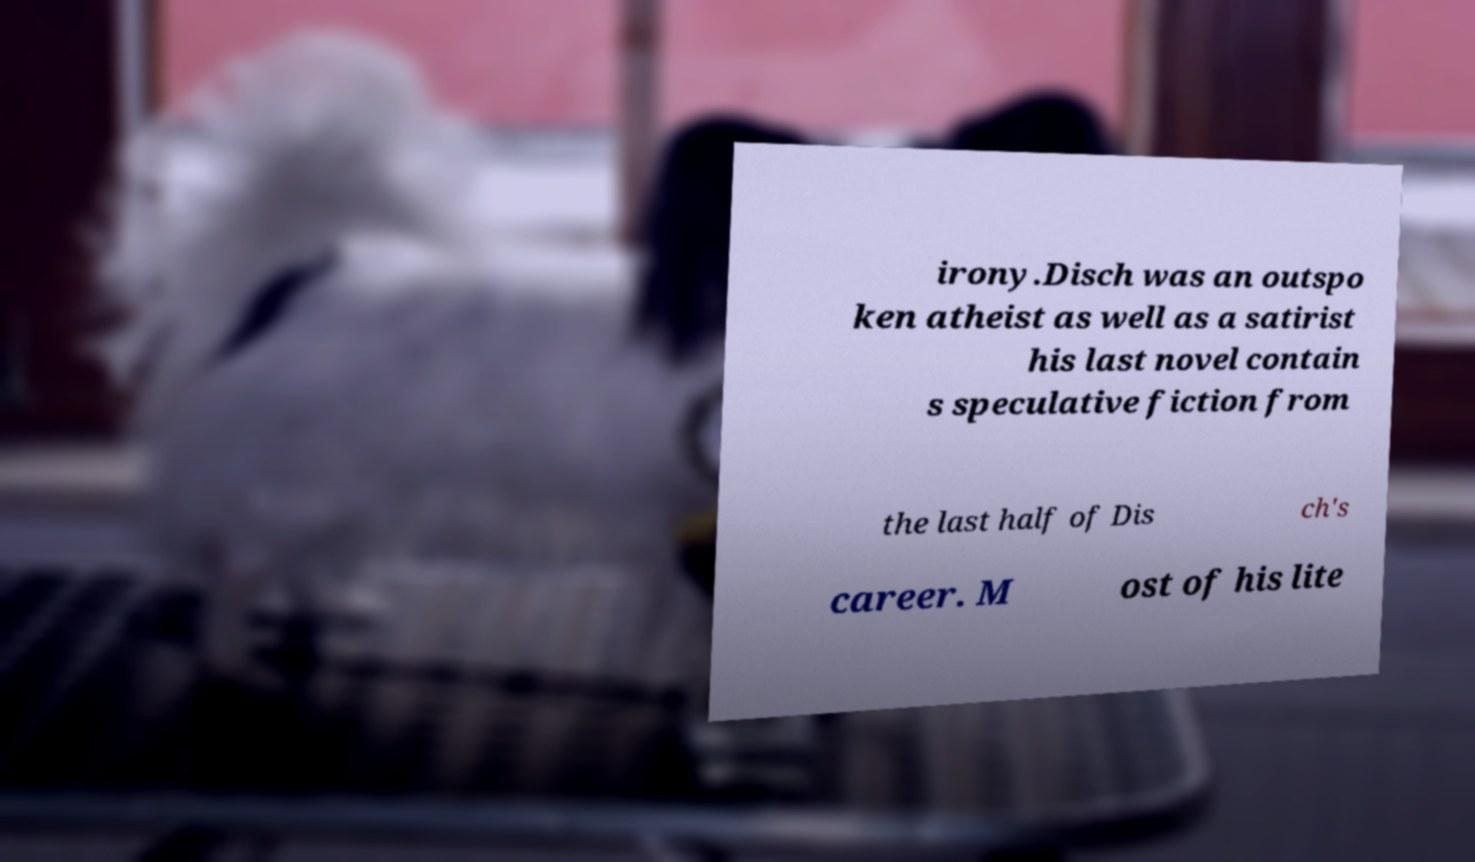Could you extract and type out the text from this image? irony.Disch was an outspo ken atheist as well as a satirist his last novel contain s speculative fiction from the last half of Dis ch's career. M ost of his lite 